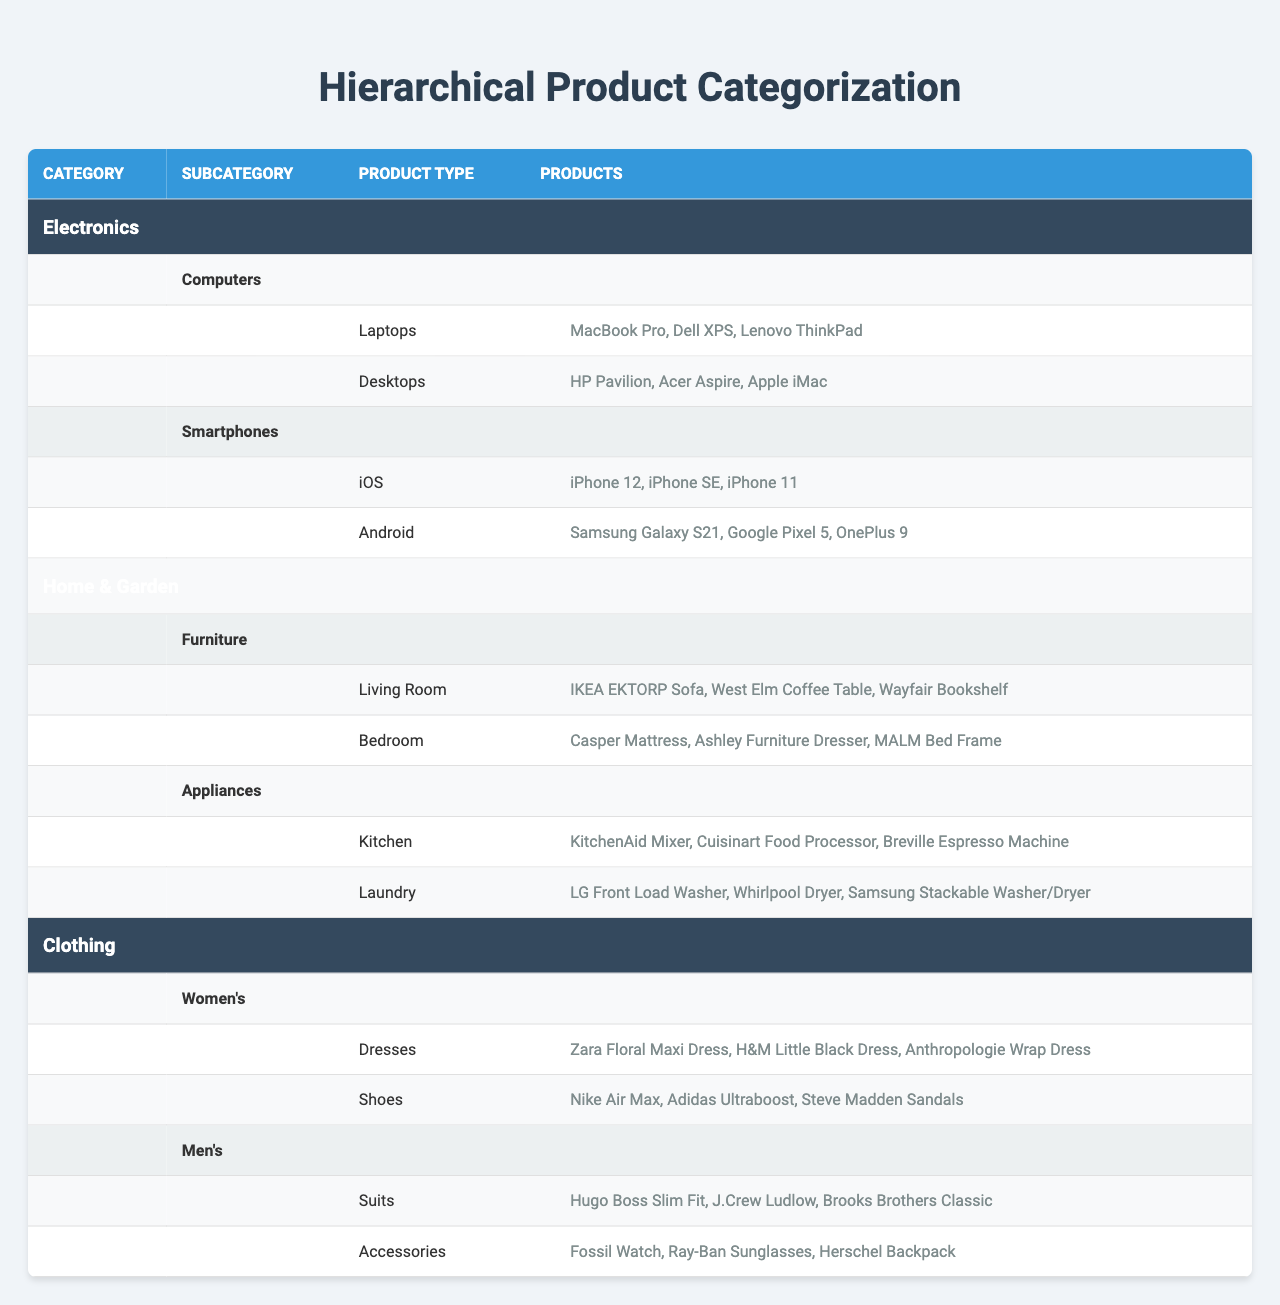What is the highest-level category in the table? The highest-level categories listed are "Electronics," "Home & Garden," and "Clothing."
Answer: Electronics, Home & Garden, Clothing How many subcategories are under "Electronics"? "Electronics" has two subcategories: "Computers" and "Smartphones."
Answer: 2 What products are listed under the "Laptops" subcategory? The "Laptops" subcategory includes "MacBook Pro," "Dell XPS," and "Lenovo ThinkPad."
Answer: MacBook Pro, Dell XPS, Lenovo ThinkPad How many products are there under the "Women's" clothing category? Under "Women's," there are two product types: "Dresses" and "Shoes," with three products each. So, the total is 3 + 3 = 6.
Answer: 6 Are there any "Android" smartphones listed in the table? Yes, the "Android" subcategory includes "Samsung Galaxy S21," "Google Pixel 5," and "OnePlus 9."
Answer: Yes Which category has more subcategories: "Home & Garden" or "Electronics"? "Home & Garden" has two subcategories ("Furniture" and "Appliances"), while "Electronics" also has two subcategories ("Computers" and "Smartphones"). Thus, both categories have the same number of subcategories.
Answer: They have the same number What is the total number of products listed under "Appliances"? "Appliances" has two subcategories: "Kitchen" with three products and "Laundry" with three products. Therefore, total products are 3 + 3 = 6.
Answer: 6 Which product appears under both "Men's" and "Women's" categories? The table does not list any overlapping products between "Men's" and "Women's" categories. Each category has distinct products.
Answer: No overlapping products How many different product types are there in the "Clothing" category? The "Clothing" category has two subcategories: "Women's" with two product types ("Dresses," "Shoes") and "Men's" with two product types ("Suits," "Accessories"). Therefore, there are a total of 2 + 2 = 4 different product types.
Answer: 4 List all the products found under "Furniture." The "Furniture" subcategory includes "IKEA EKTORP Sofa," "West Elm Coffee Table," and "Wayfair Bookshelf."
Answer: IKEA EKTORP Sofa, West Elm Coffee Table, Wayfair Bookshelf Which smartphones fall under the "iOS" subcategory? The "iOS" subcategory lists "iPhone 12," "iPhone SE," and "iPhone 11."
Answer: iPhone 12, iPhone SE, iPhone 11 